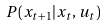Convert formula to latex. <formula><loc_0><loc_0><loc_500><loc_500>P ( x _ { t + 1 } | x _ { t } , u _ { t } )</formula> 